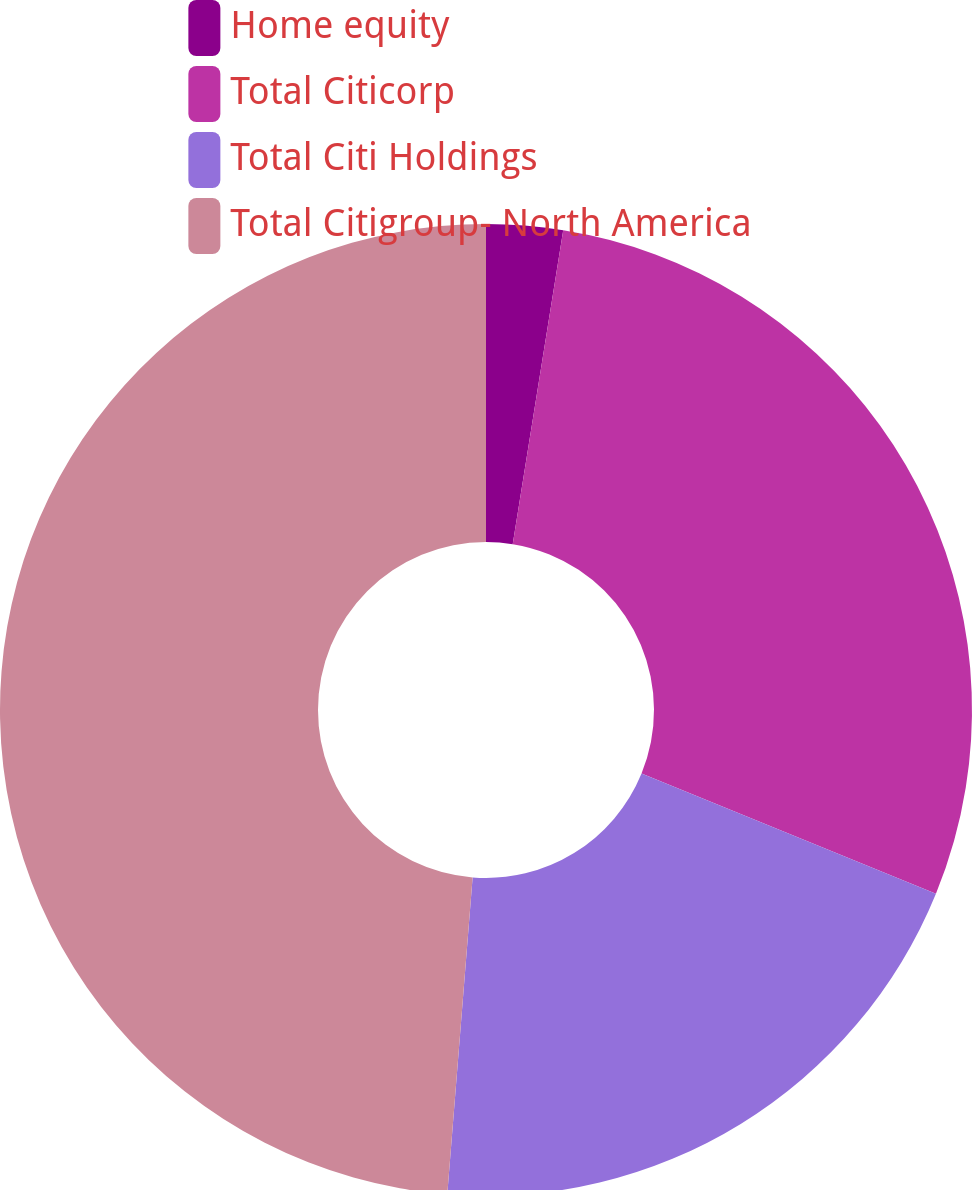<chart> <loc_0><loc_0><loc_500><loc_500><pie_chart><fcel>Home equity<fcel>Total Citicorp<fcel>Total Citi Holdings<fcel>Total Citigroup- North America<nl><fcel>2.54%<fcel>28.63%<fcel>20.1%<fcel>48.73%<nl></chart> 